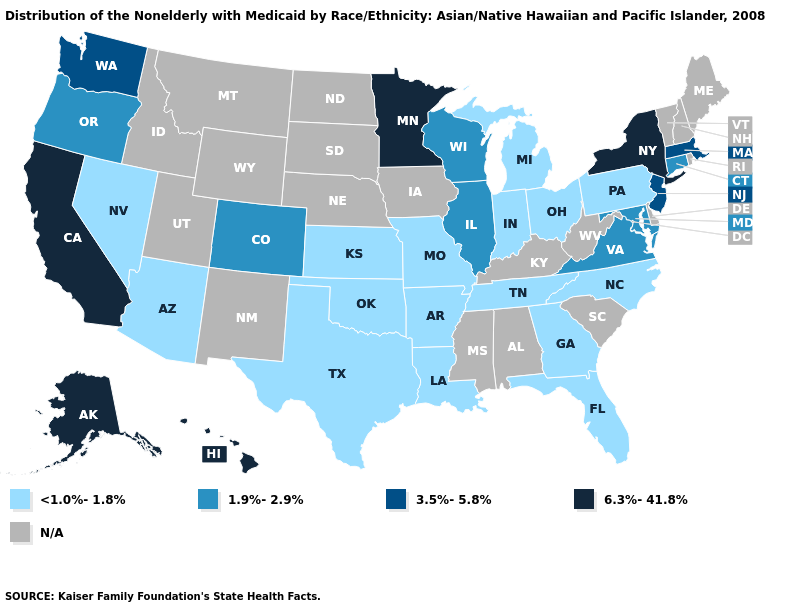What is the value of New Hampshire?
Keep it brief. N/A. What is the value of South Dakota?
Short answer required. N/A. What is the value of New Hampshire?
Keep it brief. N/A. Name the states that have a value in the range <1.0%-1.8%?
Concise answer only. Arizona, Arkansas, Florida, Georgia, Indiana, Kansas, Louisiana, Michigan, Missouri, Nevada, North Carolina, Ohio, Oklahoma, Pennsylvania, Tennessee, Texas. What is the value of Iowa?
Concise answer only. N/A. What is the value of Illinois?
Quick response, please. 1.9%-2.9%. Among the states that border Oregon , does California have the highest value?
Keep it brief. Yes. What is the value of Wyoming?
Short answer required. N/A. Which states hav the highest value in the South?
Keep it brief. Maryland, Virginia. What is the highest value in the South ?
Be succinct. 1.9%-2.9%. Among the states that border Idaho , does Oregon have the highest value?
Answer briefly. No. Name the states that have a value in the range 3.5%-5.8%?
Be succinct. Massachusetts, New Jersey, Washington. Among the states that border Utah , which have the highest value?
Concise answer only. Colorado. 